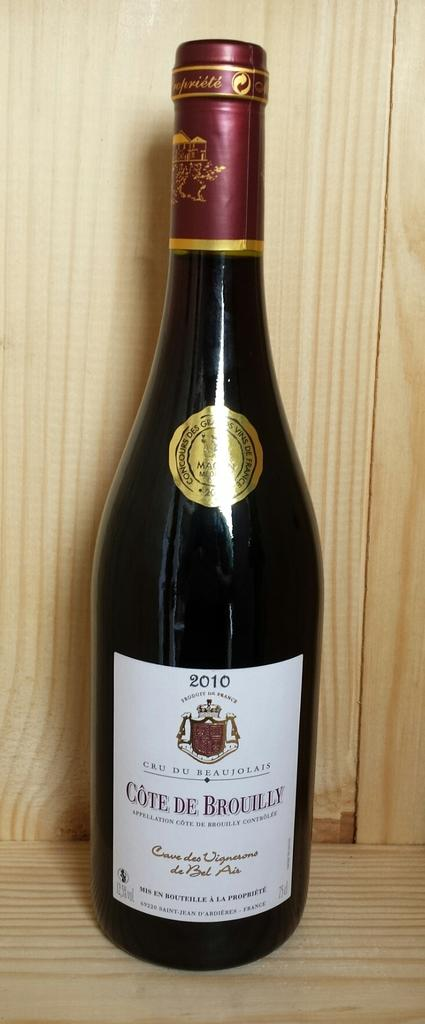Provide a one-sentence caption for the provided image. A 2010 bottle of Cote de Brouilly that was bottled in France. 